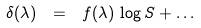Convert formula to latex. <formula><loc_0><loc_0><loc_500><loc_500>\delta ( \lambda ) \ = \ f ( \lambda ) \, \log S + \dots</formula> 